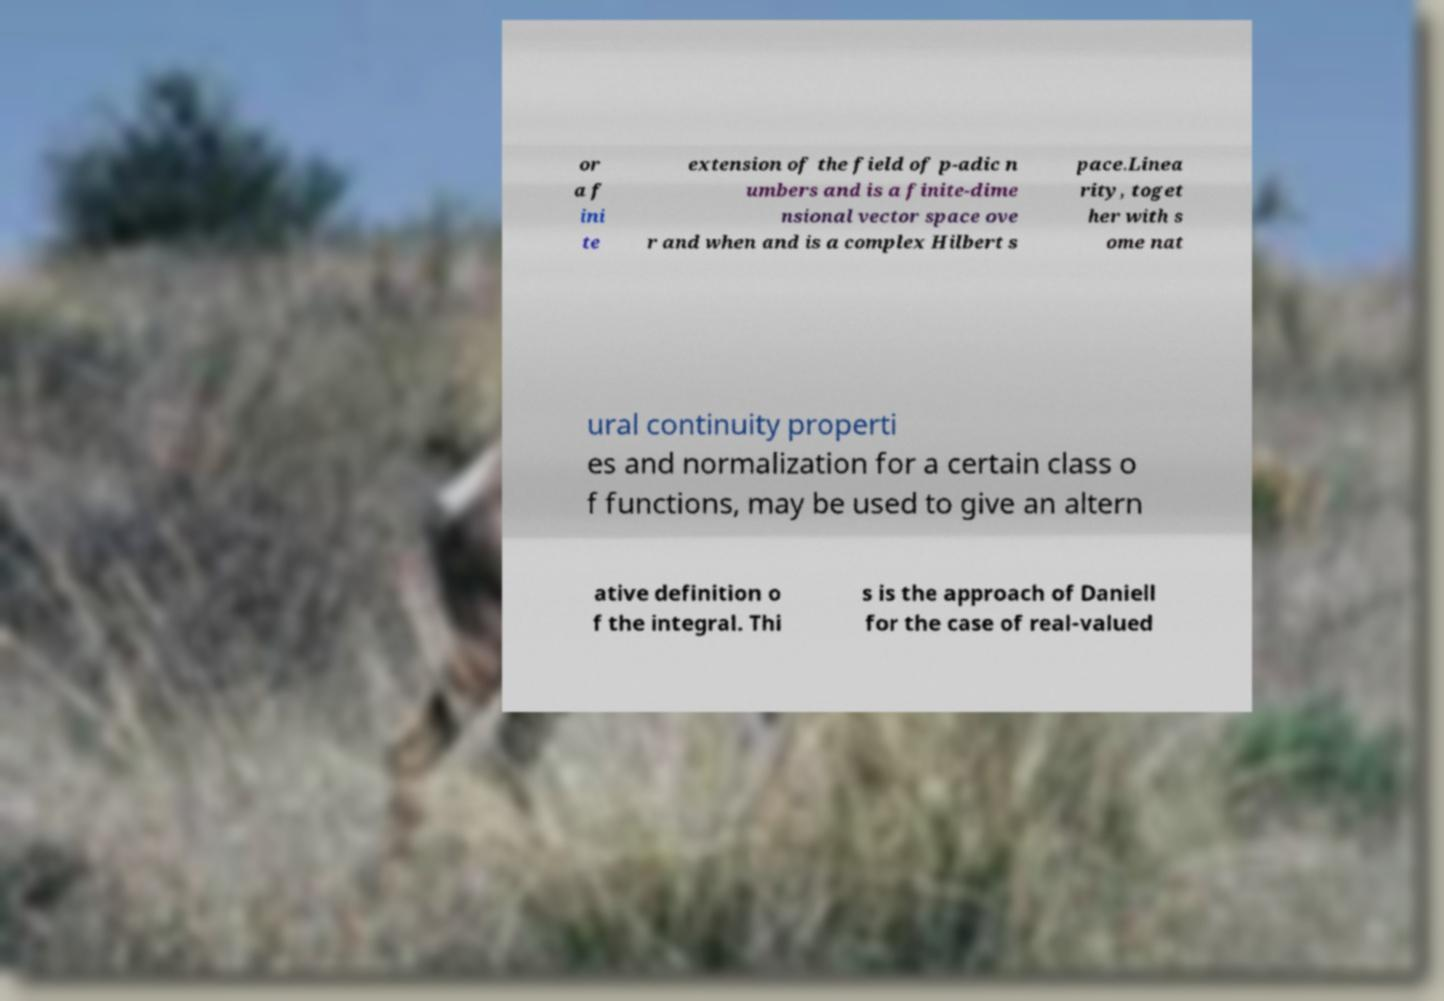Please identify and transcribe the text found in this image. or a f ini te extension of the field of p-adic n umbers and is a finite-dime nsional vector space ove r and when and is a complex Hilbert s pace.Linea rity, toget her with s ome nat ural continuity properti es and normalization for a certain class o f functions, may be used to give an altern ative definition o f the integral. Thi s is the approach of Daniell for the case of real-valued 